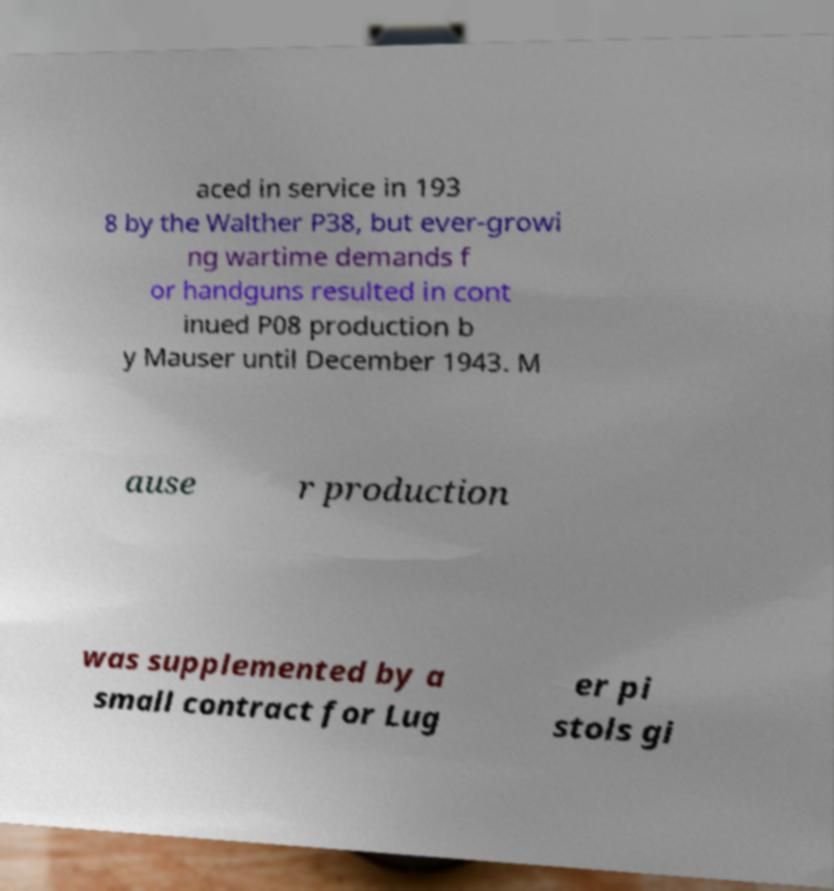Could you assist in decoding the text presented in this image and type it out clearly? aced in service in 193 8 by the Walther P38, but ever-growi ng wartime demands f or handguns resulted in cont inued P08 production b y Mauser until December 1943. M ause r production was supplemented by a small contract for Lug er pi stols gi 